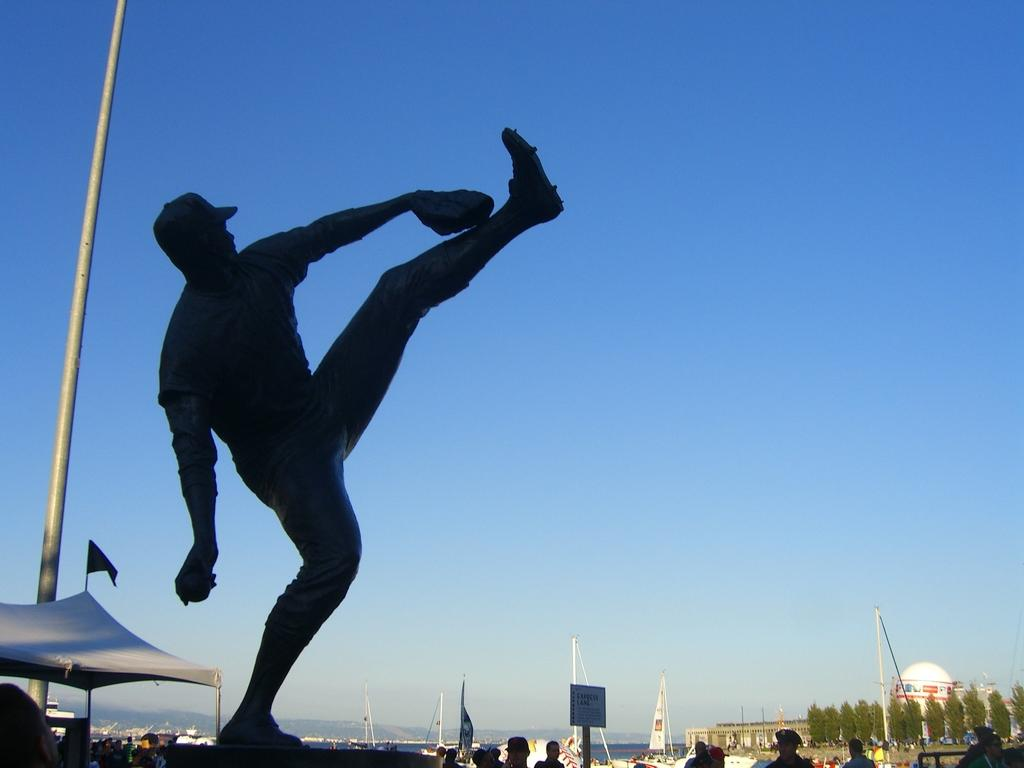What is present in the image? There are people and flags in the image. What else can be seen in the image? There are trees in the image. What is visible in the background of the image? The sky is visible in the image. Where is the tub located in the image? There is no tub present in the image. What type of pets can be seen in the image? There are no pets visible in the image. 